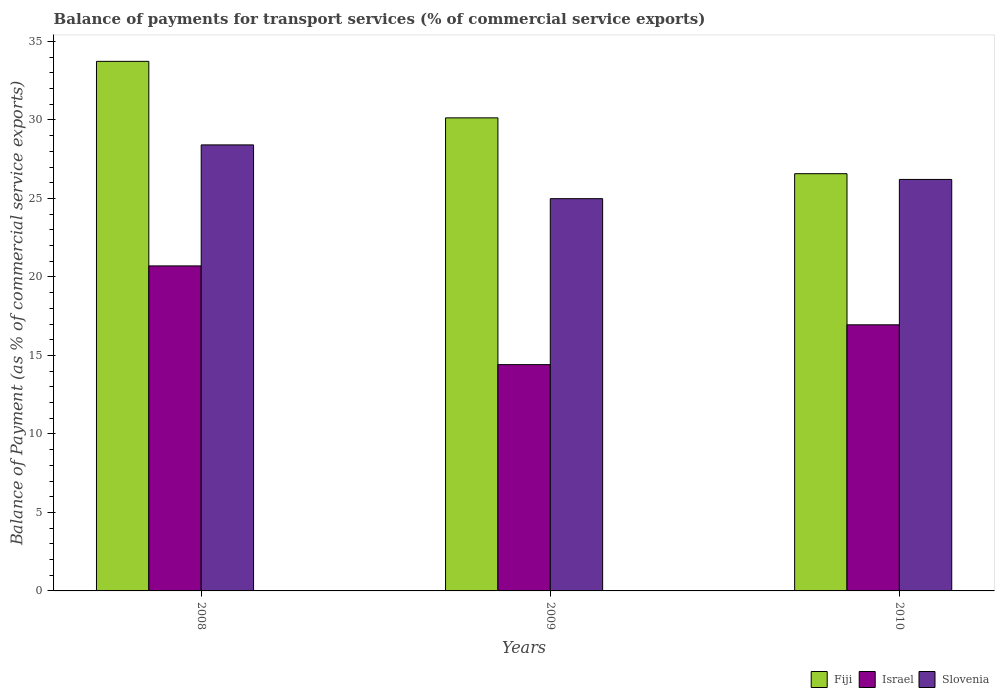How many different coloured bars are there?
Provide a succinct answer. 3. Are the number of bars on each tick of the X-axis equal?
Provide a succinct answer. Yes. How many bars are there on the 2nd tick from the left?
Keep it short and to the point. 3. What is the label of the 2nd group of bars from the left?
Make the answer very short. 2009. What is the balance of payments for transport services in Israel in 2009?
Provide a succinct answer. 14.41. Across all years, what is the maximum balance of payments for transport services in Slovenia?
Make the answer very short. 28.41. Across all years, what is the minimum balance of payments for transport services in Slovenia?
Ensure brevity in your answer.  24.99. What is the total balance of payments for transport services in Slovenia in the graph?
Offer a terse response. 79.61. What is the difference between the balance of payments for transport services in Slovenia in 2009 and that in 2010?
Keep it short and to the point. -1.22. What is the difference between the balance of payments for transport services in Fiji in 2008 and the balance of payments for transport services in Slovenia in 2010?
Ensure brevity in your answer.  7.52. What is the average balance of payments for transport services in Israel per year?
Give a very brief answer. 17.36. In the year 2009, what is the difference between the balance of payments for transport services in Israel and balance of payments for transport services in Slovenia?
Provide a succinct answer. -10.57. What is the ratio of the balance of payments for transport services in Fiji in 2009 to that in 2010?
Provide a succinct answer. 1.13. What is the difference between the highest and the second highest balance of payments for transport services in Israel?
Give a very brief answer. 3.75. What is the difference between the highest and the lowest balance of payments for transport services in Slovenia?
Your answer should be very brief. 3.42. What does the 3rd bar from the left in 2010 represents?
Ensure brevity in your answer.  Slovenia. Is it the case that in every year, the sum of the balance of payments for transport services in Israel and balance of payments for transport services in Slovenia is greater than the balance of payments for transport services in Fiji?
Keep it short and to the point. Yes. Are the values on the major ticks of Y-axis written in scientific E-notation?
Offer a terse response. No. Does the graph contain any zero values?
Offer a terse response. No. Does the graph contain grids?
Provide a short and direct response. No. Where does the legend appear in the graph?
Your answer should be very brief. Bottom right. How many legend labels are there?
Offer a very short reply. 3. How are the legend labels stacked?
Give a very brief answer. Horizontal. What is the title of the graph?
Your response must be concise. Balance of payments for transport services (% of commercial service exports). What is the label or title of the Y-axis?
Offer a terse response. Balance of Payment (as % of commercial service exports). What is the Balance of Payment (as % of commercial service exports) in Fiji in 2008?
Offer a very short reply. 33.73. What is the Balance of Payment (as % of commercial service exports) of Israel in 2008?
Ensure brevity in your answer.  20.7. What is the Balance of Payment (as % of commercial service exports) of Slovenia in 2008?
Your answer should be compact. 28.41. What is the Balance of Payment (as % of commercial service exports) of Fiji in 2009?
Your answer should be very brief. 30.13. What is the Balance of Payment (as % of commercial service exports) of Israel in 2009?
Offer a very short reply. 14.41. What is the Balance of Payment (as % of commercial service exports) of Slovenia in 2009?
Your answer should be compact. 24.99. What is the Balance of Payment (as % of commercial service exports) in Fiji in 2010?
Ensure brevity in your answer.  26.58. What is the Balance of Payment (as % of commercial service exports) in Israel in 2010?
Offer a very short reply. 16.95. What is the Balance of Payment (as % of commercial service exports) of Slovenia in 2010?
Keep it short and to the point. 26.21. Across all years, what is the maximum Balance of Payment (as % of commercial service exports) in Fiji?
Ensure brevity in your answer.  33.73. Across all years, what is the maximum Balance of Payment (as % of commercial service exports) in Israel?
Provide a succinct answer. 20.7. Across all years, what is the maximum Balance of Payment (as % of commercial service exports) of Slovenia?
Provide a succinct answer. 28.41. Across all years, what is the minimum Balance of Payment (as % of commercial service exports) of Fiji?
Provide a succinct answer. 26.58. Across all years, what is the minimum Balance of Payment (as % of commercial service exports) in Israel?
Ensure brevity in your answer.  14.41. Across all years, what is the minimum Balance of Payment (as % of commercial service exports) in Slovenia?
Your answer should be compact. 24.99. What is the total Balance of Payment (as % of commercial service exports) in Fiji in the graph?
Your answer should be very brief. 90.44. What is the total Balance of Payment (as % of commercial service exports) of Israel in the graph?
Your answer should be very brief. 52.07. What is the total Balance of Payment (as % of commercial service exports) of Slovenia in the graph?
Your answer should be very brief. 79.61. What is the difference between the Balance of Payment (as % of commercial service exports) in Fiji in 2008 and that in 2009?
Make the answer very short. 3.6. What is the difference between the Balance of Payment (as % of commercial service exports) of Israel in 2008 and that in 2009?
Provide a succinct answer. 6.29. What is the difference between the Balance of Payment (as % of commercial service exports) in Slovenia in 2008 and that in 2009?
Keep it short and to the point. 3.42. What is the difference between the Balance of Payment (as % of commercial service exports) of Fiji in 2008 and that in 2010?
Your response must be concise. 7.16. What is the difference between the Balance of Payment (as % of commercial service exports) in Israel in 2008 and that in 2010?
Keep it short and to the point. 3.75. What is the difference between the Balance of Payment (as % of commercial service exports) of Slovenia in 2008 and that in 2010?
Offer a terse response. 2.2. What is the difference between the Balance of Payment (as % of commercial service exports) in Fiji in 2009 and that in 2010?
Offer a terse response. 3.56. What is the difference between the Balance of Payment (as % of commercial service exports) of Israel in 2009 and that in 2010?
Your answer should be compact. -2.54. What is the difference between the Balance of Payment (as % of commercial service exports) in Slovenia in 2009 and that in 2010?
Provide a succinct answer. -1.22. What is the difference between the Balance of Payment (as % of commercial service exports) of Fiji in 2008 and the Balance of Payment (as % of commercial service exports) of Israel in 2009?
Provide a short and direct response. 19.32. What is the difference between the Balance of Payment (as % of commercial service exports) in Fiji in 2008 and the Balance of Payment (as % of commercial service exports) in Slovenia in 2009?
Offer a terse response. 8.75. What is the difference between the Balance of Payment (as % of commercial service exports) of Israel in 2008 and the Balance of Payment (as % of commercial service exports) of Slovenia in 2009?
Offer a very short reply. -4.28. What is the difference between the Balance of Payment (as % of commercial service exports) of Fiji in 2008 and the Balance of Payment (as % of commercial service exports) of Israel in 2010?
Provide a short and direct response. 16.78. What is the difference between the Balance of Payment (as % of commercial service exports) in Fiji in 2008 and the Balance of Payment (as % of commercial service exports) in Slovenia in 2010?
Make the answer very short. 7.52. What is the difference between the Balance of Payment (as % of commercial service exports) in Israel in 2008 and the Balance of Payment (as % of commercial service exports) in Slovenia in 2010?
Provide a short and direct response. -5.51. What is the difference between the Balance of Payment (as % of commercial service exports) in Fiji in 2009 and the Balance of Payment (as % of commercial service exports) in Israel in 2010?
Make the answer very short. 13.18. What is the difference between the Balance of Payment (as % of commercial service exports) of Fiji in 2009 and the Balance of Payment (as % of commercial service exports) of Slovenia in 2010?
Keep it short and to the point. 3.92. What is the difference between the Balance of Payment (as % of commercial service exports) in Israel in 2009 and the Balance of Payment (as % of commercial service exports) in Slovenia in 2010?
Provide a short and direct response. -11.8. What is the average Balance of Payment (as % of commercial service exports) of Fiji per year?
Your answer should be very brief. 30.15. What is the average Balance of Payment (as % of commercial service exports) in Israel per year?
Offer a very short reply. 17.36. What is the average Balance of Payment (as % of commercial service exports) in Slovenia per year?
Keep it short and to the point. 26.54. In the year 2008, what is the difference between the Balance of Payment (as % of commercial service exports) of Fiji and Balance of Payment (as % of commercial service exports) of Israel?
Give a very brief answer. 13.03. In the year 2008, what is the difference between the Balance of Payment (as % of commercial service exports) of Fiji and Balance of Payment (as % of commercial service exports) of Slovenia?
Provide a short and direct response. 5.32. In the year 2008, what is the difference between the Balance of Payment (as % of commercial service exports) of Israel and Balance of Payment (as % of commercial service exports) of Slovenia?
Give a very brief answer. -7.71. In the year 2009, what is the difference between the Balance of Payment (as % of commercial service exports) of Fiji and Balance of Payment (as % of commercial service exports) of Israel?
Give a very brief answer. 15.72. In the year 2009, what is the difference between the Balance of Payment (as % of commercial service exports) in Fiji and Balance of Payment (as % of commercial service exports) in Slovenia?
Ensure brevity in your answer.  5.15. In the year 2009, what is the difference between the Balance of Payment (as % of commercial service exports) in Israel and Balance of Payment (as % of commercial service exports) in Slovenia?
Offer a very short reply. -10.57. In the year 2010, what is the difference between the Balance of Payment (as % of commercial service exports) of Fiji and Balance of Payment (as % of commercial service exports) of Israel?
Your answer should be compact. 9.63. In the year 2010, what is the difference between the Balance of Payment (as % of commercial service exports) of Fiji and Balance of Payment (as % of commercial service exports) of Slovenia?
Your answer should be compact. 0.37. In the year 2010, what is the difference between the Balance of Payment (as % of commercial service exports) of Israel and Balance of Payment (as % of commercial service exports) of Slovenia?
Your answer should be very brief. -9.26. What is the ratio of the Balance of Payment (as % of commercial service exports) in Fiji in 2008 to that in 2009?
Provide a short and direct response. 1.12. What is the ratio of the Balance of Payment (as % of commercial service exports) in Israel in 2008 to that in 2009?
Make the answer very short. 1.44. What is the ratio of the Balance of Payment (as % of commercial service exports) in Slovenia in 2008 to that in 2009?
Make the answer very short. 1.14. What is the ratio of the Balance of Payment (as % of commercial service exports) of Fiji in 2008 to that in 2010?
Keep it short and to the point. 1.27. What is the ratio of the Balance of Payment (as % of commercial service exports) of Israel in 2008 to that in 2010?
Offer a very short reply. 1.22. What is the ratio of the Balance of Payment (as % of commercial service exports) in Slovenia in 2008 to that in 2010?
Give a very brief answer. 1.08. What is the ratio of the Balance of Payment (as % of commercial service exports) in Fiji in 2009 to that in 2010?
Your answer should be very brief. 1.13. What is the ratio of the Balance of Payment (as % of commercial service exports) of Israel in 2009 to that in 2010?
Give a very brief answer. 0.85. What is the ratio of the Balance of Payment (as % of commercial service exports) in Slovenia in 2009 to that in 2010?
Offer a terse response. 0.95. What is the difference between the highest and the second highest Balance of Payment (as % of commercial service exports) of Fiji?
Make the answer very short. 3.6. What is the difference between the highest and the second highest Balance of Payment (as % of commercial service exports) in Israel?
Offer a terse response. 3.75. What is the difference between the highest and the second highest Balance of Payment (as % of commercial service exports) in Slovenia?
Provide a succinct answer. 2.2. What is the difference between the highest and the lowest Balance of Payment (as % of commercial service exports) in Fiji?
Provide a short and direct response. 7.16. What is the difference between the highest and the lowest Balance of Payment (as % of commercial service exports) of Israel?
Provide a short and direct response. 6.29. What is the difference between the highest and the lowest Balance of Payment (as % of commercial service exports) in Slovenia?
Provide a short and direct response. 3.42. 